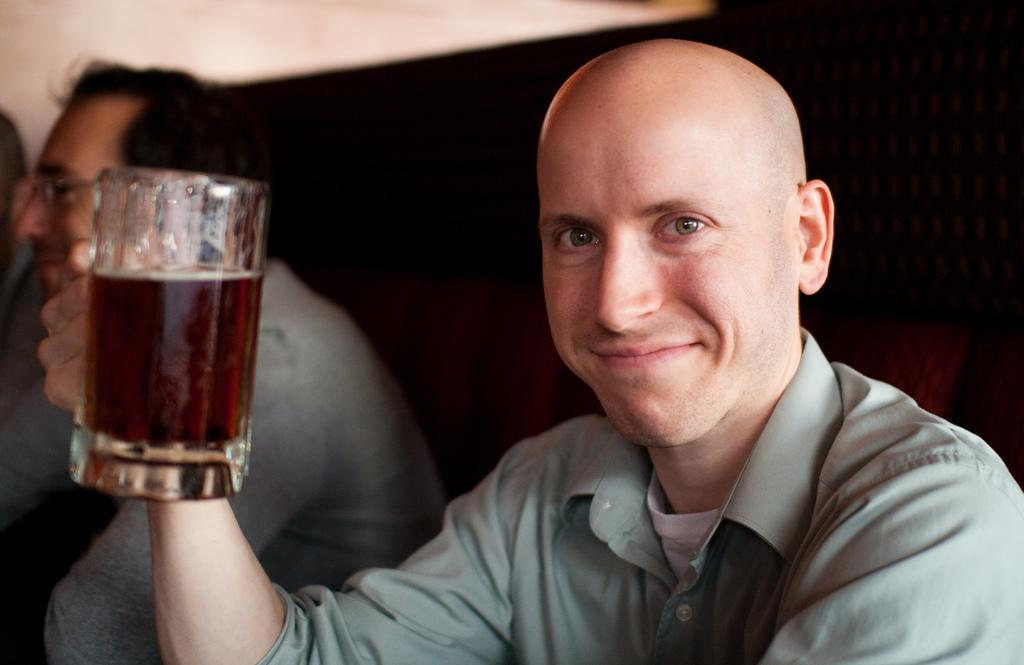What is the person in the image doing? The person is sitting and smiling in the image. What is the person holding in the image? The person is holding a glass. What can be seen in the background of the image? There is a wall and other persons sitting in the background of the image. What type of stamp can be seen on the person's forehead in the image? There is no stamp present on the person's forehead in the image. 